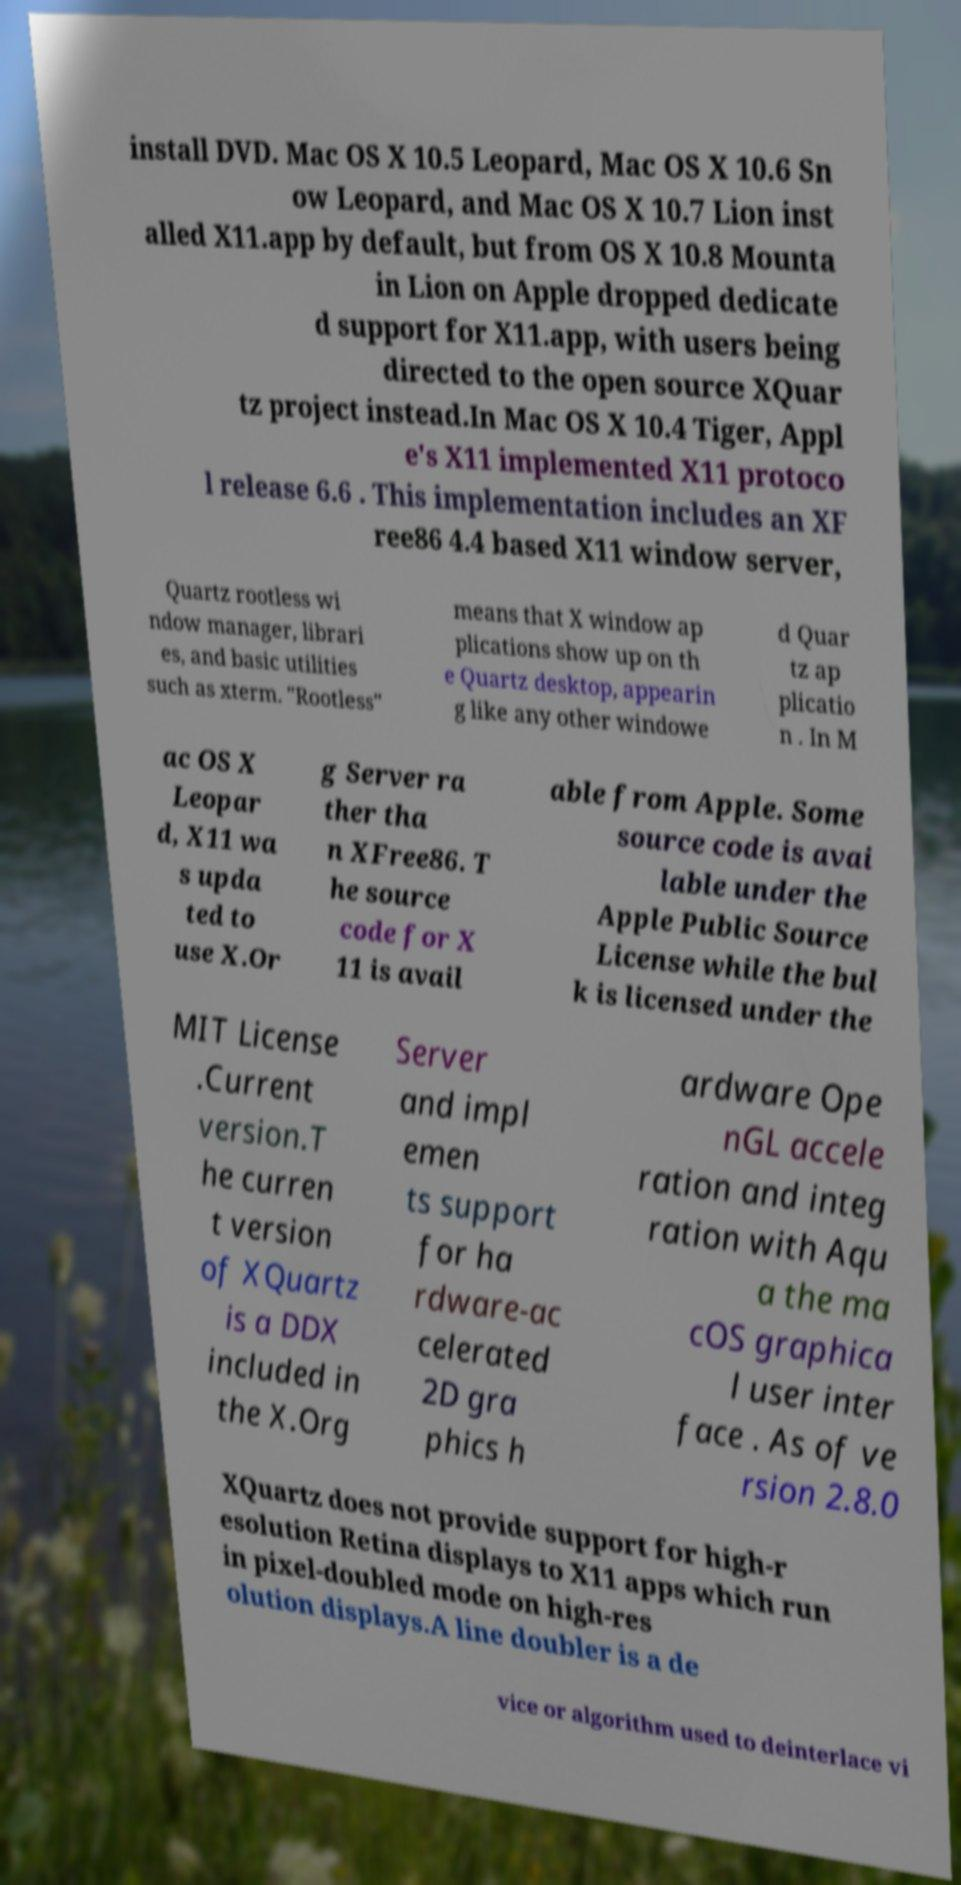Could you extract and type out the text from this image? install DVD. Mac OS X 10.5 Leopard, Mac OS X 10.6 Sn ow Leopard, and Mac OS X 10.7 Lion inst alled X11.app by default, but from OS X 10.8 Mounta in Lion on Apple dropped dedicate d support for X11.app, with users being directed to the open source XQuar tz project instead.In Mac OS X 10.4 Tiger, Appl e's X11 implemented X11 protoco l release 6.6 . This implementation includes an XF ree86 4.4 based X11 window server, Quartz rootless wi ndow manager, librari es, and basic utilities such as xterm. "Rootless" means that X window ap plications show up on th e Quartz desktop, appearin g like any other windowe d Quar tz ap plicatio n . In M ac OS X Leopar d, X11 wa s upda ted to use X.Or g Server ra ther tha n XFree86. T he source code for X 11 is avail able from Apple. Some source code is avai lable under the Apple Public Source License while the bul k is licensed under the MIT License .Current version.T he curren t version of XQuartz is a DDX included in the X.Org Server and impl emen ts support for ha rdware-ac celerated 2D gra phics h ardware Ope nGL accele ration and integ ration with Aqu a the ma cOS graphica l user inter face . As of ve rsion 2.8.0 XQuartz does not provide support for high-r esolution Retina displays to X11 apps which run in pixel-doubled mode on high-res olution displays.A line doubler is a de vice or algorithm used to deinterlace vi 